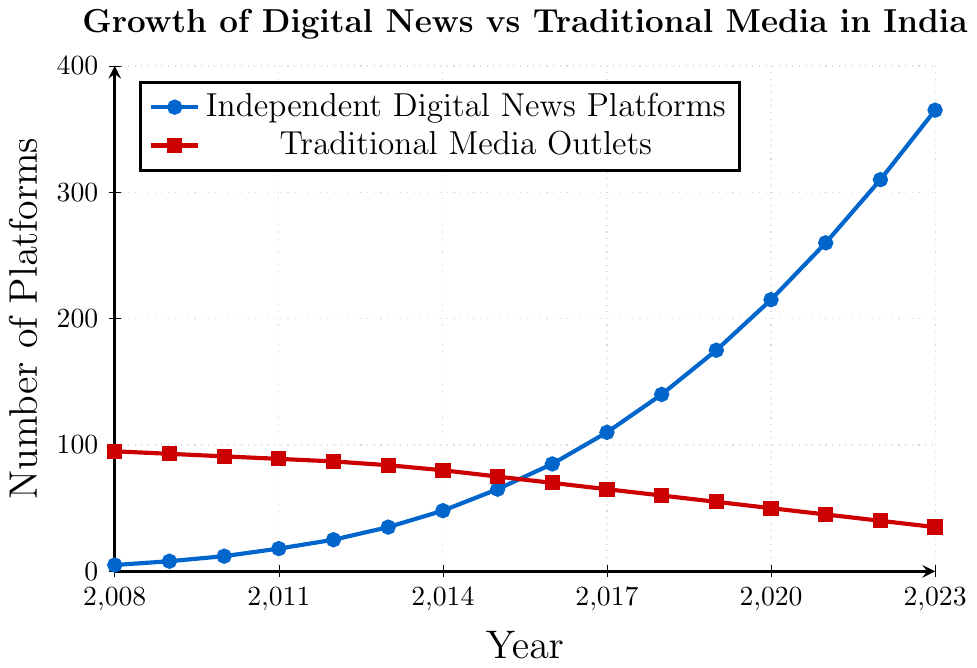What year did Independent Digital News Platforms surpass 100 platforms? Look at the blue line for Independent Digital News Platforms and find the first year when the count exceeds 100. This corresponds to the year 2017.
Answer: 2017 By how much did the number of Traditional Media Outlets decrease from 2008 to 2023? Compare the values for Traditional Media Outlets in 2008 (95) and 2023 (35). Subtract the 2023 value from the 2008 value: 95 - 35 = 60.
Answer: 60 Which type of media had a steeper growth rate between 2015 and 2020? Look at the slope of the blue line (Independent Digital) vs. the red line (Traditional Media) between 2015 and 2020. The blue line shows a much sharper increase from 65 to 215 compared to a gentler decline of the red line from 75 to 50.
Answer: Independent Digital What was the average number of Independent Digital News Platforms from 2008 to 2023? Add up all the values for Independent Digital News Platforms from 2008 to 2023 and divide by the number of years (16). This equals (5 + 8 + 12 + 18 + 25 + 35 + 48 + 65 + 85 + 110 + 140 + 175 + 215 + 260 + 310 + 365) / 16 = 105.
Answer: 105 In which year was the number of Traditional Media Outlets exactly 50% of that in 2008? Find the value that's 50% of the 2008 Traditional Media Outlets value, which is 95 * 0.5 = 47.5. Rounding to the nearest whole number, the closest value is 50 in the year 2020.
Answer: 2020 Compare the growth rates of Independent Digital News Platforms and Traditional Media Outlets over the past 15 years. Independent Digital News Platforms increased from 5 to 365, which is a growth of 360. Traditional Media Outlets decreased from 95 to 35, resulting in a decrease of 60. The larger numerical change and increase in Independent Digital News Platforms indicate a much higher growth rate compared to the decreasing trend of Traditional Media Outlets.
Answer: Digital significantly higher How many more Independent Digital News Platforms were there in 2023 compared to 2010? Find the values for Independent Digital News Platforms in 2023 (365) and 2010 (12). The difference is 365 - 12 = 353.
Answer: 353 What is the trend for Traditional Media Outlets over the last 15 years? Observe the red line, which starts at 95 in 2008 and decreases consistently each year to 35 in 2023. The trend is a steady decline.
Answer: Steady decline 